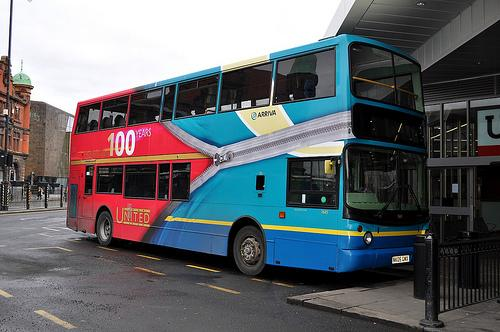What type of road is the bus stopped on and what is its notable feature? The bus is stopped on an asphalt road with yellow markings on it. What are the unique features on the windshield of the bus? The windshield wipers are visible on the bus windshield. Mention any unique design or imagery visible on the side of the bus. There is an image of a zipper on the side of the bus. List out the text and numbers visible on the bus. United is written on the side of the bus, and the number is 100. How many levels of passenger windows does the bus have and what is their appearance? The bus has two levels of passenger windows, and they appear dark. Describe the tires of the bus and their condition. The front and back tires of the bus are black, and their condition seems normal. Identify the type of bus in the image and its primary colors. The bus is a double decker and is blue and red in color. Describe the building on the left side of the road and its main features. The building on the left side of the road is orange with glass windows and a door. What are the main colors and visible elements of the image? Blue, red, white, black, yellow, and orange are the main colors, and elements include a double decker bus, an asphalt road with markings, an overcast sky, wet floor, and buildings with glass windows. Explain the condition of the road and the sky in the image. The road is wet, and the sky is overcast. Imagine a dialogue between a passenger and a bus driver on this bus. Write a brief conversation including appropriate greetings and questions about the bus route. Passenger: "Hello, is this the number 100 bus to City Center?" What type of vehicle is stopped at the bus station? A double decker bus. Describe the building next to the bus in terms of its color and features. The building next to the bus is orange and has glass windows and a door. Identify an event taking place in the image. The bus is stopped at the bus station. Describe the appearance of the yellow markings on the road in the image. The yellow markings on the road are horizontal lines. Choose the correct option regarding the presence of a building in the image: A) There is a green building on the right side of the road B) There is an orange building on the left side of the road C) There is no building in the image. B) There is an orange building on the left side of the road. Identify any important visible features on the bus windshield. Windshield wipers are visible. Is the double decker bus at the bus station blue and red? Yes. List the colors and visible features of the double decker bus at the bus station. The double decker bus is blue and red, has the number 100 on its side, a license plate, yellow markings on the road, and a passenger window section on the second level. Write a brief paragraph describing the scene in the image. In the overcast image, a blue and red double decker bus with the number 100 on its side is stopped at a bus station. On the left side of the road, there is an orange building with glass windows and a door. The floor is wet, and there are yellow markings on the asphalt road. What activity is happening on this street? A bus is stopped at a bus station. Read the text written on the side of the bus. United. What is the expression of any person in the image? There are no visible people in the image. Describe the style and design of the bus station. There is not enough information to describe the bus station's style and design. Describe the various visible parts of the bus, such as the tires, windows, and license plate. The visible parts of the bus include black tires, yellow markings on the road, a white license plate, windshield wipers, headlights, and a passenger window section on the second level. Describe the physical appearance of the bus tires in the image. The bus tires are black, one front tire is visible on the lower left side and one back tire on the lower right side. Read the license plate number on the front of the bus. The license plate is not readable. Is there a fence in the image? If so, what color is it? Yes, there is a black fence in the image. What is the condition of the road in the image? The road is wet. 